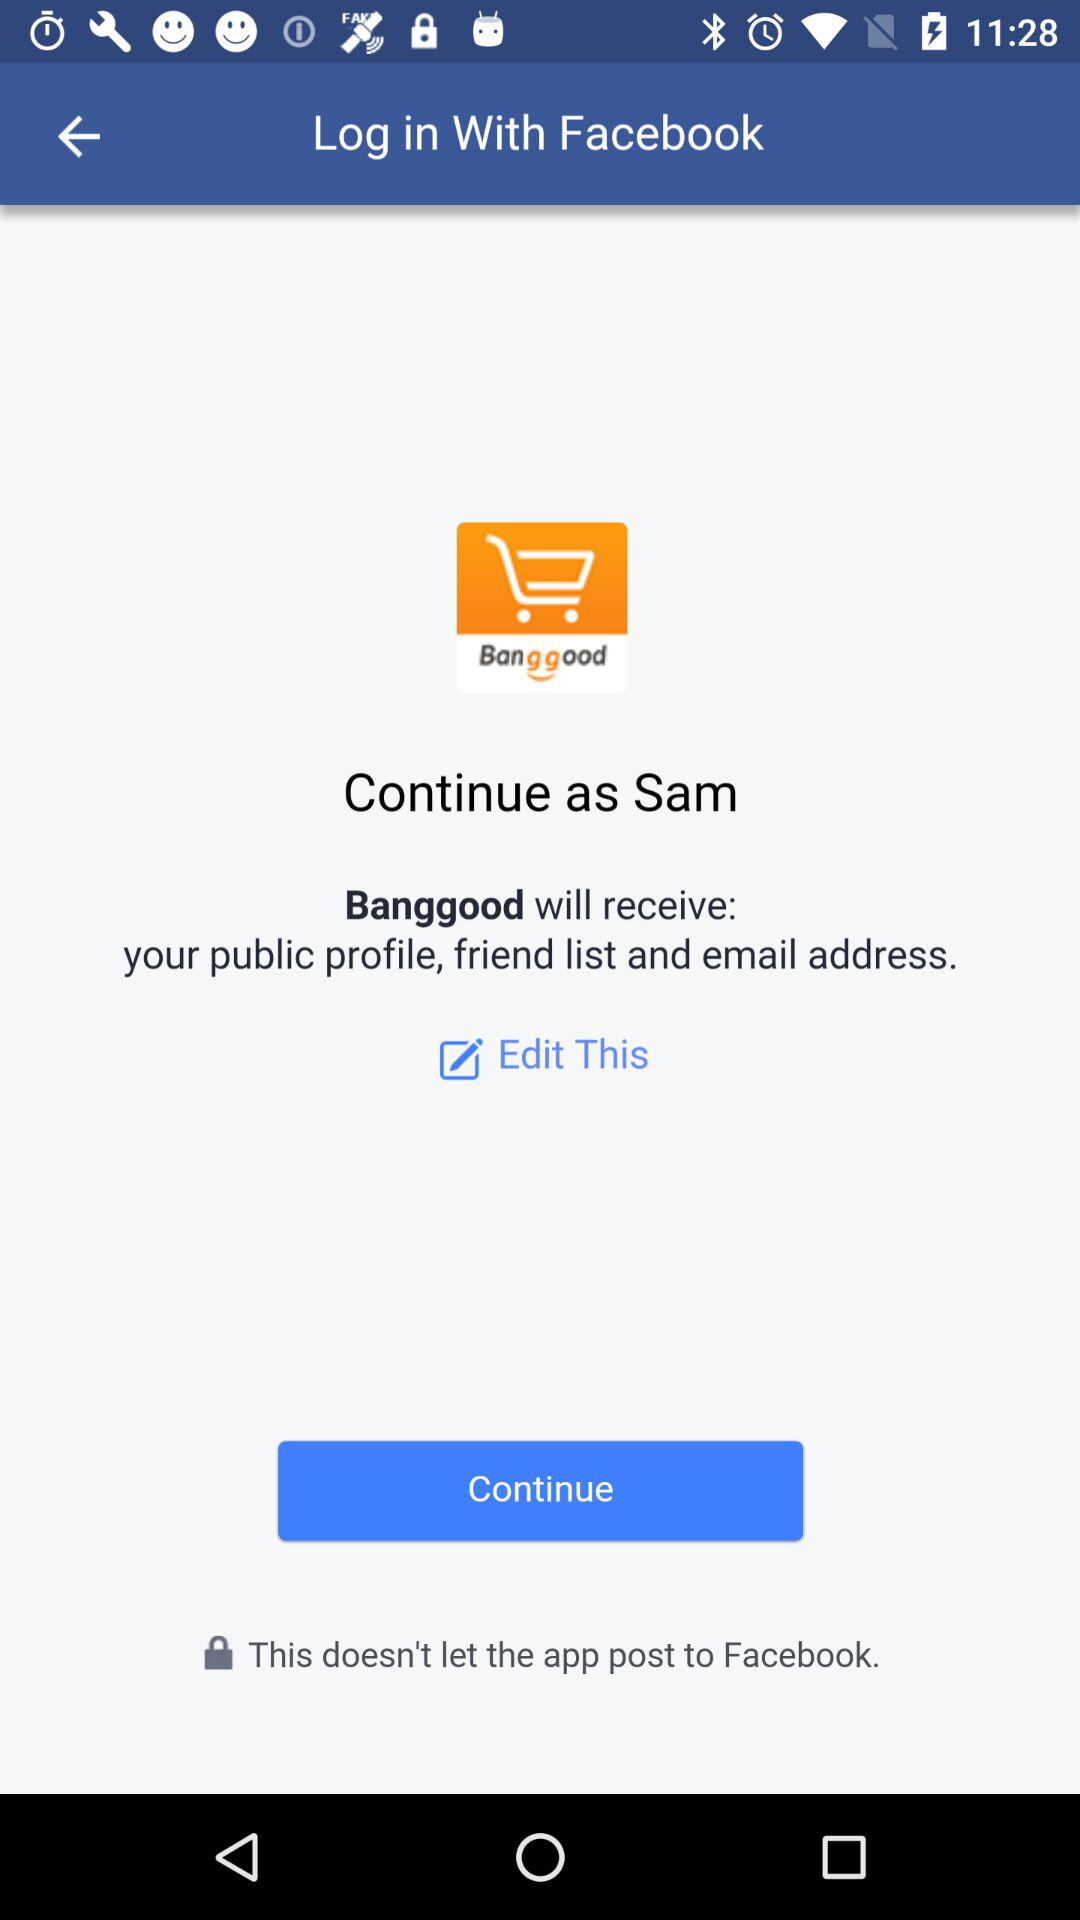What application are we using to log in? The application that you are using to log in is "Facebook". 